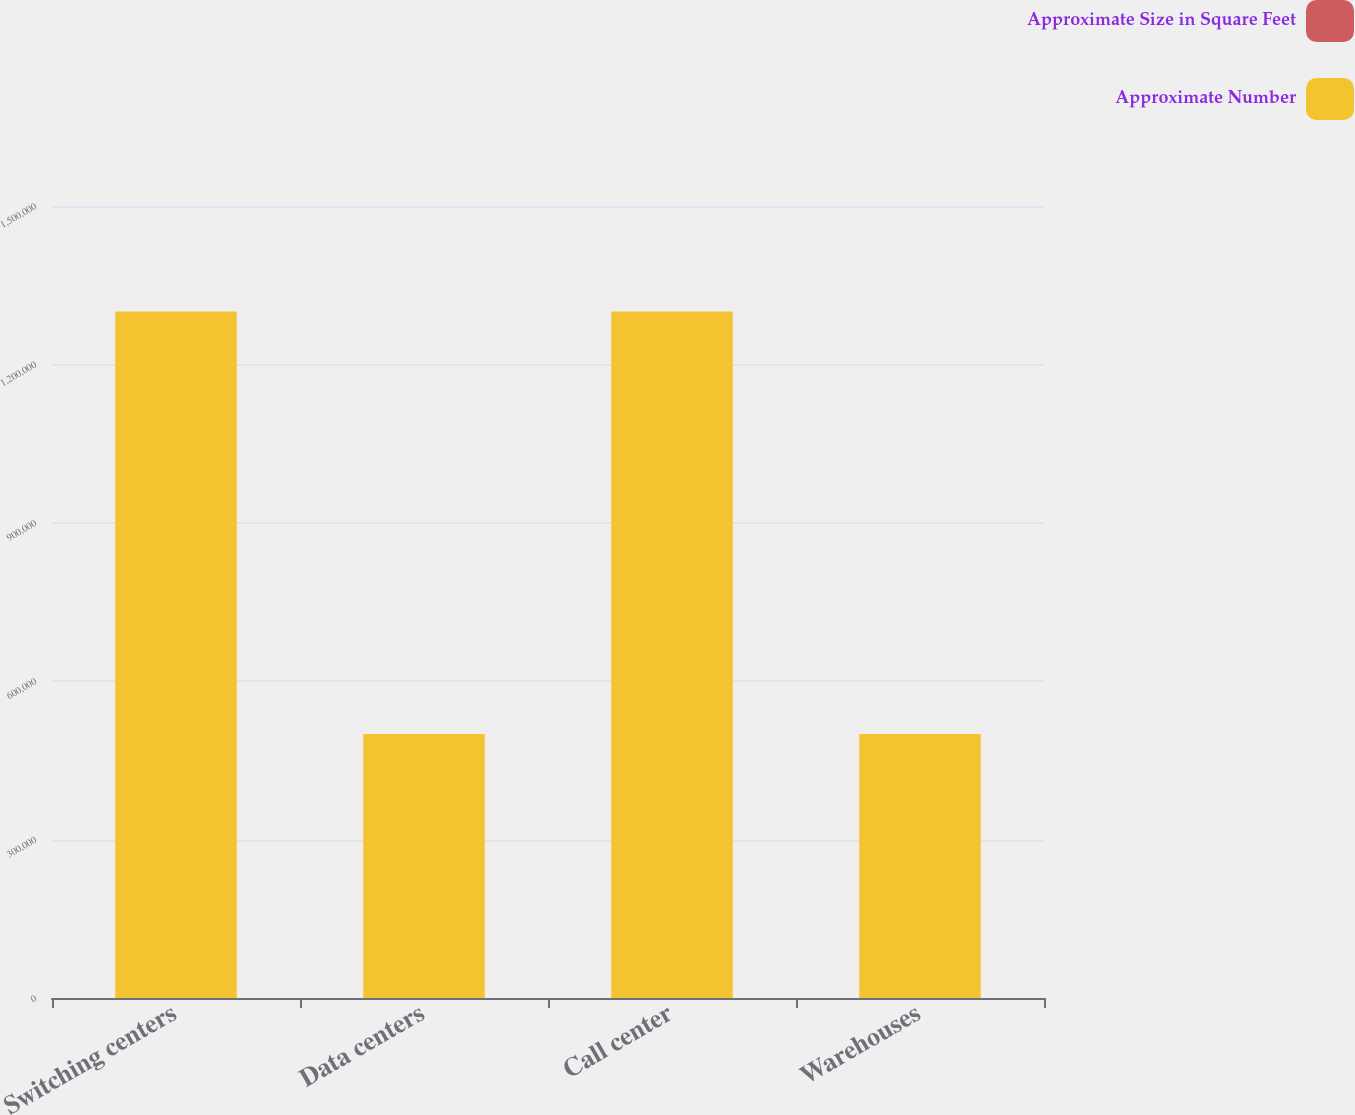Convert chart to OTSL. <chart><loc_0><loc_0><loc_500><loc_500><stacked_bar_chart><ecel><fcel>Switching centers<fcel>Data centers<fcel>Call center<fcel>Warehouses<nl><fcel>Approximate Size in Square Feet<fcel>61<fcel>6<fcel>17<fcel>21<nl><fcel>Approximate Number<fcel>1.3e+06<fcel>500000<fcel>1.3e+06<fcel>500000<nl></chart> 